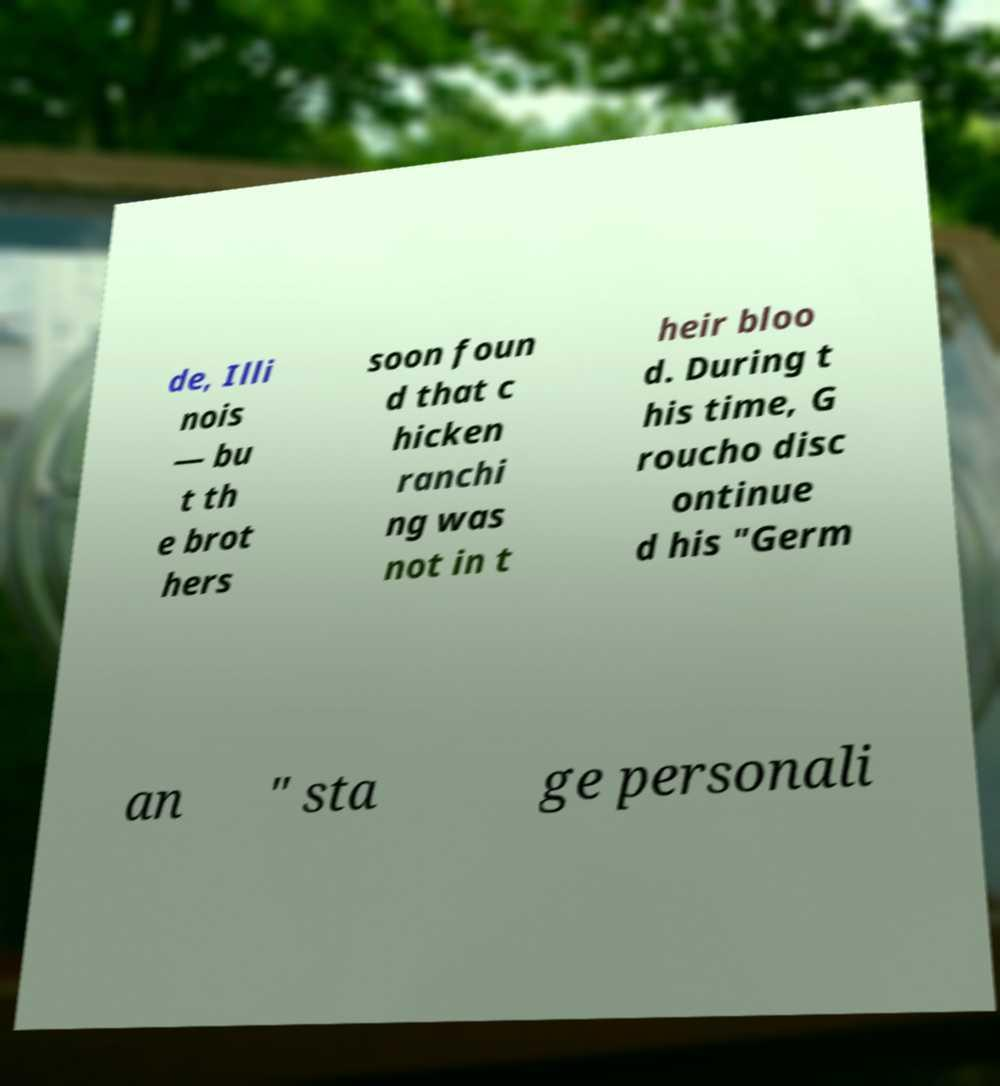Could you extract and type out the text from this image? de, Illi nois — bu t th e brot hers soon foun d that c hicken ranchi ng was not in t heir bloo d. During t his time, G roucho disc ontinue d his "Germ an " sta ge personali 